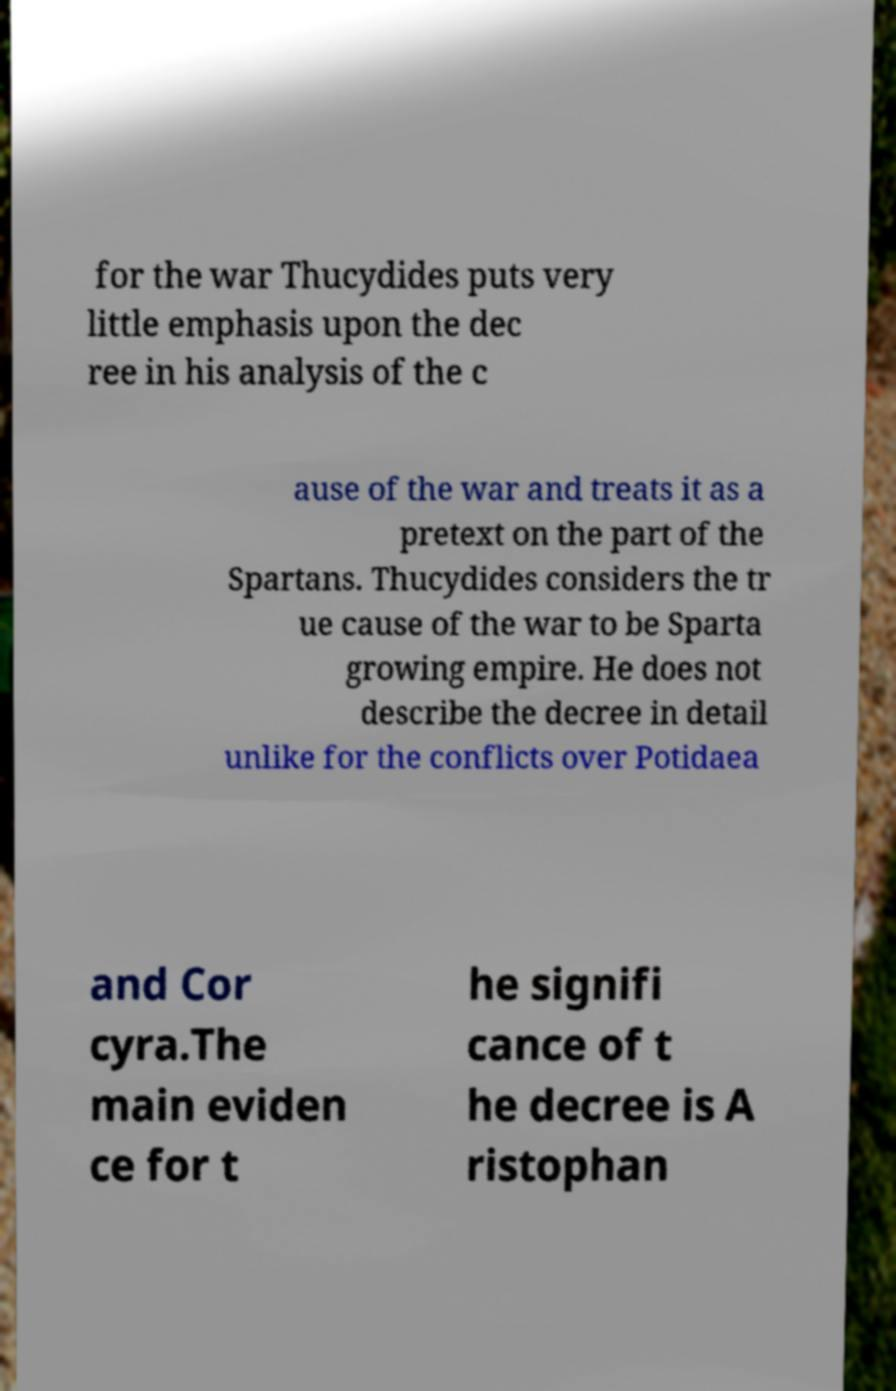Please identify and transcribe the text found in this image. for the war Thucydides puts very little emphasis upon the dec ree in his analysis of the c ause of the war and treats it as a pretext on the part of the Spartans. Thucydides considers the tr ue cause of the war to be Sparta growing empire. He does not describe the decree in detail unlike for the conflicts over Potidaea and Cor cyra.The main eviden ce for t he signifi cance of t he decree is A ristophan 